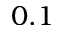<formula> <loc_0><loc_0><loc_500><loc_500>0 . 1</formula> 